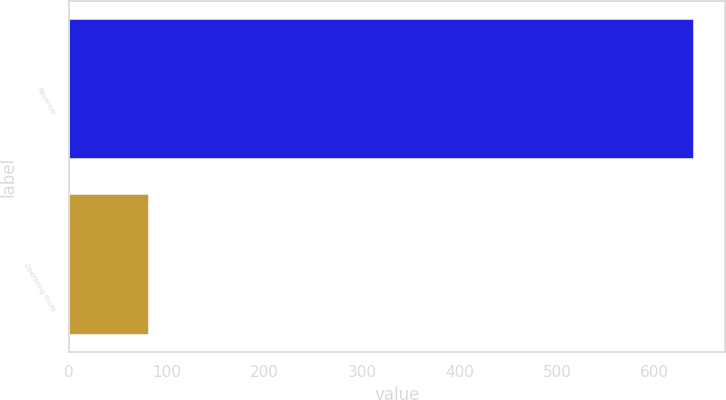Convert chart to OTSL. <chart><loc_0><loc_0><loc_500><loc_500><bar_chart><fcel>Revenue<fcel>Operating Profit<nl><fcel>640.1<fcel>82<nl></chart> 